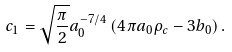<formula> <loc_0><loc_0><loc_500><loc_500>c _ { 1 } = \sqrt { \frac { \pi } { 2 } } a _ { 0 } ^ { - 7 / 4 } \left ( 4 \pi a _ { 0 } \rho _ { c } - 3 b _ { 0 } \right ) .</formula> 